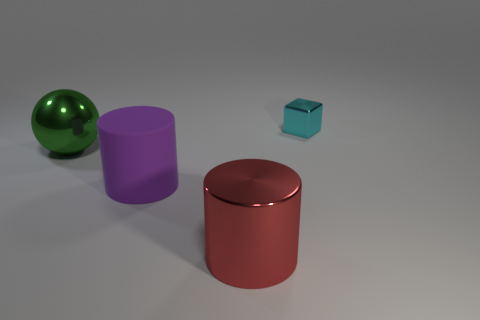Add 2 small cyan shiny cubes. How many objects exist? 6 Subtract 2 cylinders. How many cylinders are left? 0 Subtract all spheres. How many objects are left? 3 Subtract 0 gray balls. How many objects are left? 4 Subtract all yellow cubes. Subtract all green spheres. How many cubes are left? 1 Subtract all green balls. How many red cylinders are left? 1 Subtract all gray rubber cylinders. Subtract all large cylinders. How many objects are left? 2 Add 3 purple matte objects. How many purple matte objects are left? 4 Add 2 big cyan shiny cubes. How many big cyan shiny cubes exist? 2 Subtract all purple cylinders. How many cylinders are left? 1 